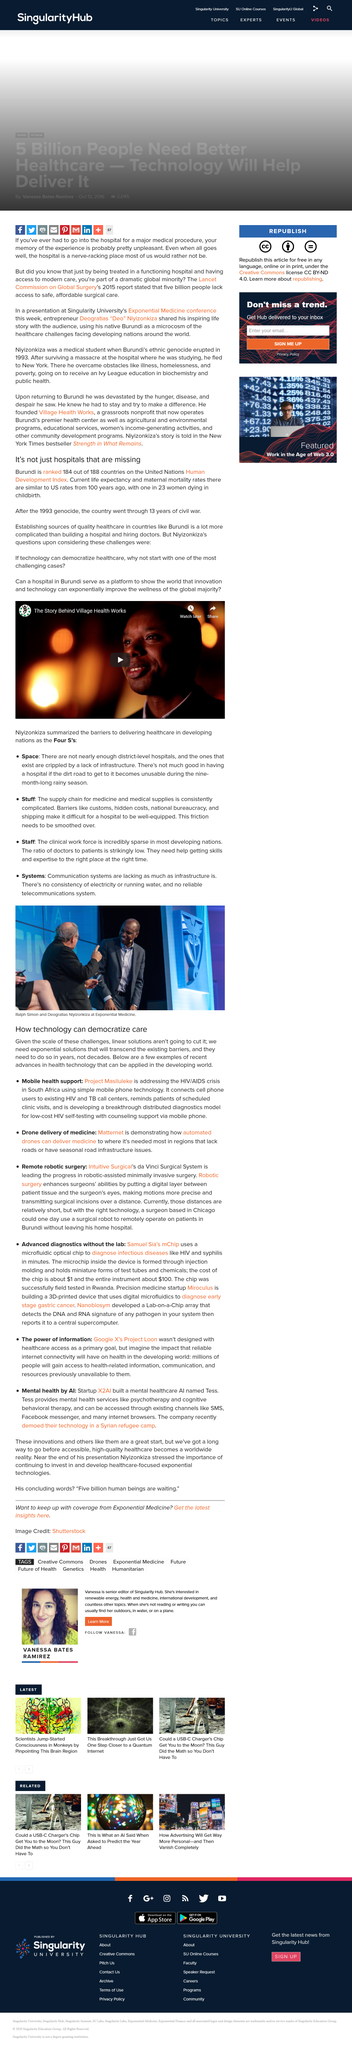Give some essential details in this illustration. Village Health Works is a nonprofit organization that provides high-quality, patient-centered healthcare services to the people of Rwanda. The organization's mission is to improve the health and well-being of Rwandans by providing access to medical care and promoting health education. The video "What is the video the story of? The story behind Village Health Works..." provides an in-depth look at the work of Village Health Works, including their innovative approach to healthcare delivery and their commitment to empowering the local community through sustainable health programs. Ralph Simon and Deogratias Niyizonkiza are clearly visible in the photograph. It is clear that linear solutions are not sufficient to address the current problem. The use of mobile health support is a means by which technology can democratize healthcare and ensure that all individuals have access to high-quality care, regardless of their socioeconomic status or geographic location. The civil war in Burundi began in 1993 and lasted for a total of 13 years. 